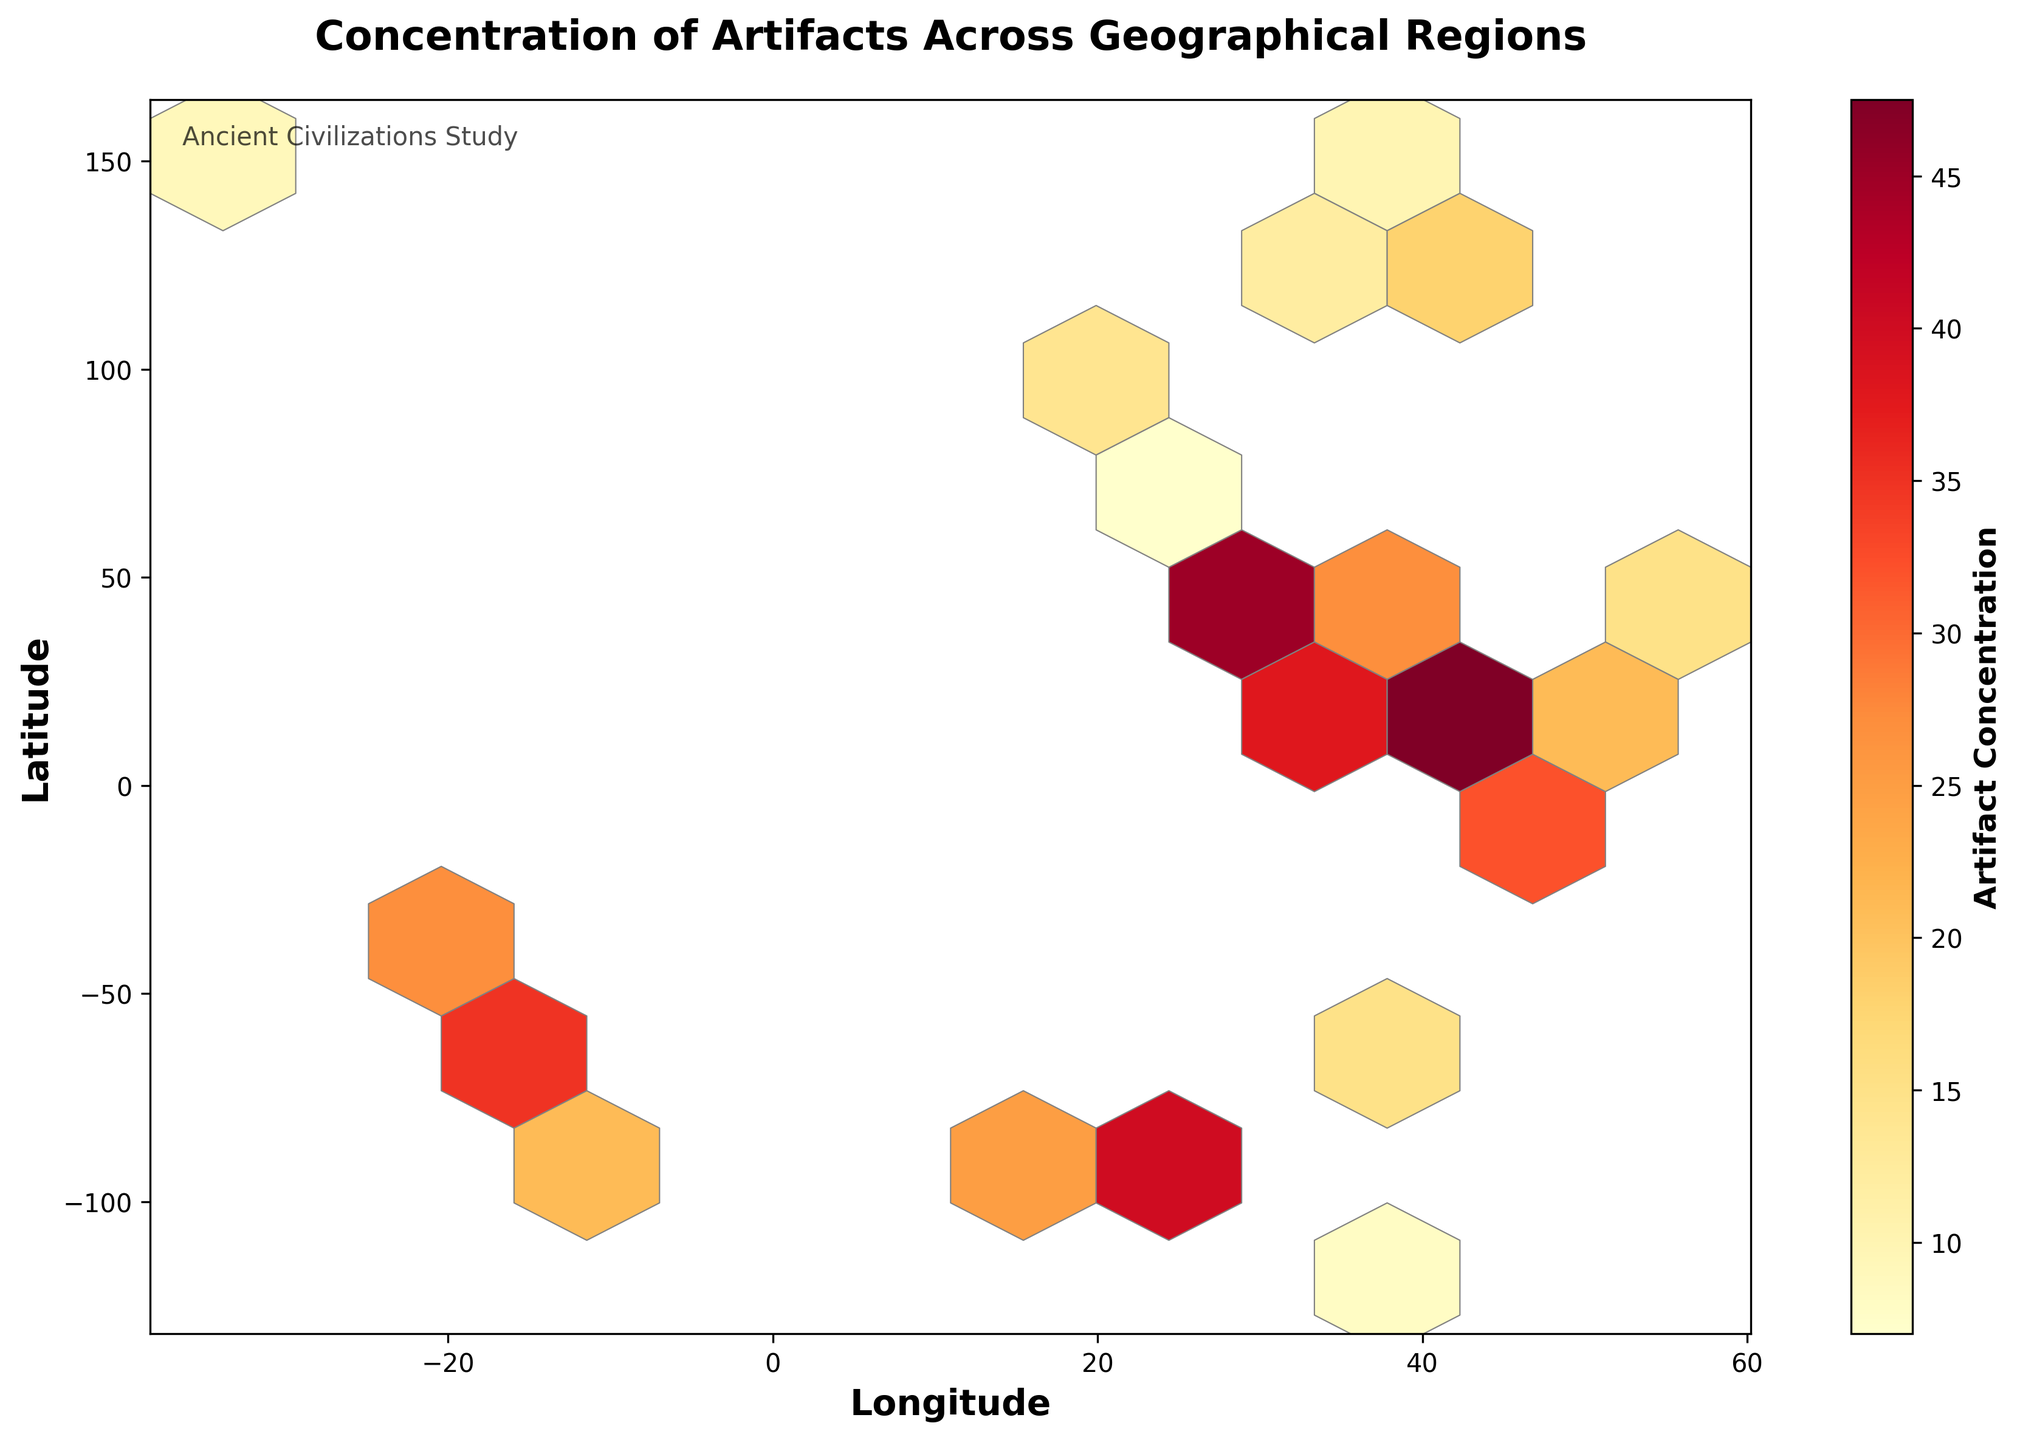What is the title of the plot? The title is placed at the top of the plot and usually summarizes the content or purpose of the visualization. In this case, it reads "Concentration of Artifacts Across Geographical Regions."
Answer: Concentration of Artifacts Across Geographical Regions What do the color variations in the hexagons represent? The color variations in the hexagons represent the concentration of artifacts. The color bar indicates the intensity of the artifact concentration, ranging from lighter to darker shades.
Answer: Artifact concentration How is the artifact concentration represented on the color bar? By looking at the color bar on the side of the plot, you can see that it represents different levels of artifact concentration, indicated by a change in color from light (low concentration) to dark (high concentration).
Answer: Gradient from light to dark What do the axes represent? The axes labels clarify the meaning: The x-axis represents 'Longitude,' and the y-axis represents 'Latitude.'
Answer: Longitude and Latitude Which region has the highest artifact concentration? By observing the darkest hexagon on the plot and cross-referencing with the location data, it appears that the area around (41.9028, 12.4964) in Rome has the highest concentration with a value of 50.
Answer: Rome What is the artifact concentration in Athens, Greece? Locate the position of Athens (37.9838, 23.7275) on the plot, and observe the color bar to interpret the corresponding concentration from the color of the hexagon. In this case, it is 45.
Answer: 45 Compare the artifact concentration between Cairo and Cairo's pyramids. Which one is higher? By locating their respective positions (Cairo: 30.0444, 31.2357 and Cairo's pyramids: 29.9792, 31.1342) on the plot and comparing their hexagon colors, we see the pyramids have a higher concentration at 48 compared to Cairo at 42.
Answer: Cairo's pyramids How are densely artifact-rich regions visually distinguished in the hexbin plot? Regions with high concentrations of artifacts are represented by darker hexagons, with darker shades indicating greater concentrations as shown by the color bar.
Answer: Darker hexagons Estimate the range of artifact concentration values found in the South American regions. Identify hexagons corresponding to South American locations (e.g., -13.1631, -72.5450 and -12.0464, -77.0428). Using the color bar, these regions range from concentrations of 21 to 35.
Answer: 21 to 35 What is the artifact concentration in Berlin, Germany, and how does it compare to that of Tehran, Iran? By locating Berlin (52.5200, 13.4050) and Tehran (35.6897, 51.3896) on the plot and using the color bar, Berlin has a concentration of 20 whereas Tehran has 23. Tehran has a slightly higher concentration.
Answer: Berlin: 20, Tehran: 23 